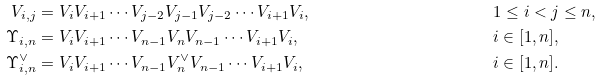<formula> <loc_0><loc_0><loc_500><loc_500>V _ { i , j } & = V _ { i } V _ { i + 1 } \cdots V _ { j - 2 } V _ { j - 1 } V _ { j - 2 } \cdots V _ { i + 1 } V _ { i } , & & 1 \leq i < j \leq n , \\ \Upsilon _ { i , n } & = V _ { i } V _ { i + 1 } \cdots V _ { n - 1 } V _ { n } V _ { n - 1 } \cdots V _ { i + 1 } V _ { i } , & & i \in [ 1 , n ] , \\ \Upsilon _ { i , n } ^ { \vee } & = V _ { i } V _ { i + 1 } \cdots V _ { n - 1 } V _ { n } ^ { \vee } V _ { n - 1 } \cdots V _ { i + 1 } V _ { i } , & & i \in [ 1 , n ] . \\</formula> 